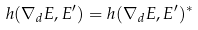<formula> <loc_0><loc_0><loc_500><loc_500>h ( \nabla _ { d } E , E ^ { \prime } ) = h ( \nabla _ { d } E , E ^ { \prime } ) ^ { \ast }</formula> 